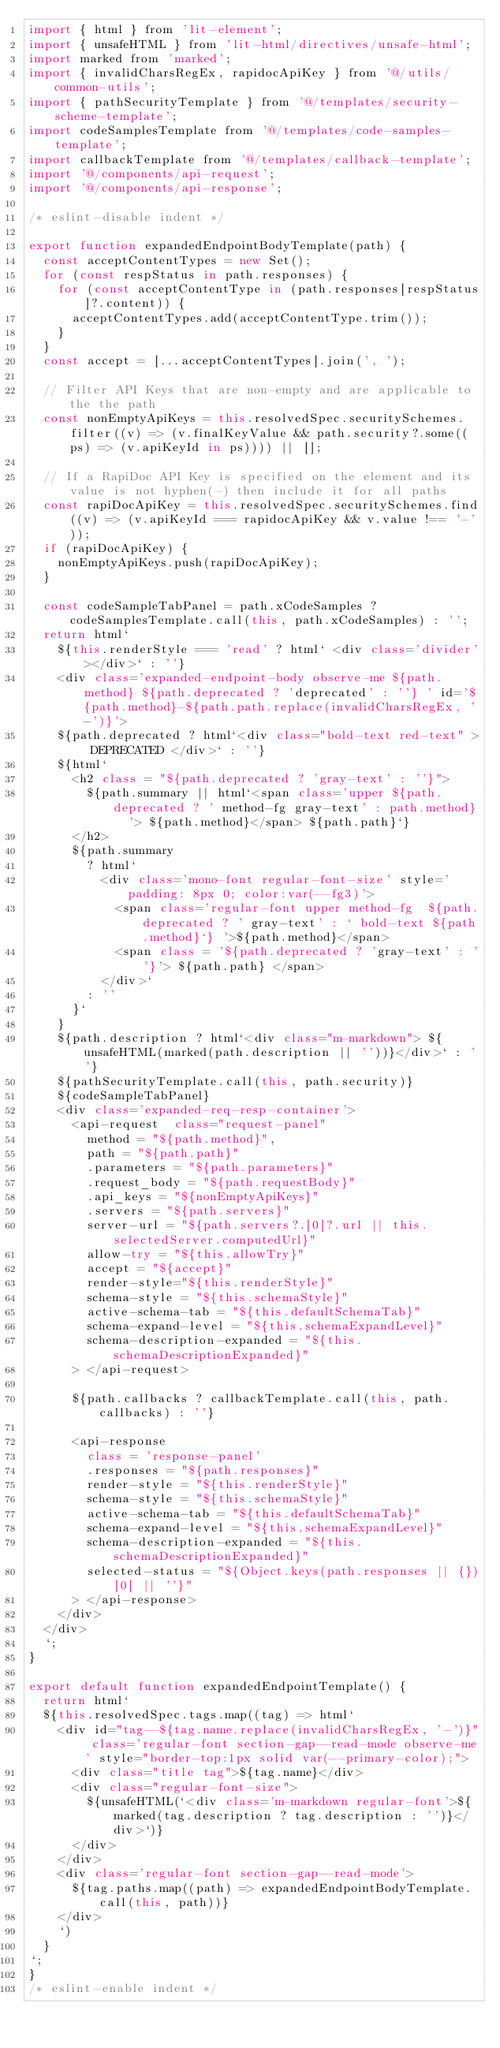<code> <loc_0><loc_0><loc_500><loc_500><_JavaScript_>import { html } from 'lit-element';
import { unsafeHTML } from 'lit-html/directives/unsafe-html';
import marked from 'marked';
import { invalidCharsRegEx, rapidocApiKey } from '@/utils/common-utils';
import { pathSecurityTemplate } from '@/templates/security-scheme-template';
import codeSamplesTemplate from '@/templates/code-samples-template';
import callbackTemplate from '@/templates/callback-template';
import '@/components/api-request';
import '@/components/api-response';

/* eslint-disable indent */

export function expandedEndpointBodyTemplate(path) {
  const acceptContentTypes = new Set();
  for (const respStatus in path.responses) {
    for (const acceptContentType in (path.responses[respStatus]?.content)) {
      acceptContentTypes.add(acceptContentType.trim());
    }
  }
  const accept = [...acceptContentTypes].join(', ');

  // Filter API Keys that are non-empty and are applicable to the the path
  const nonEmptyApiKeys = this.resolvedSpec.securitySchemes.filter((v) => (v.finalKeyValue && path.security?.some((ps) => (v.apiKeyId in ps)))) || [];

  // If a RapiDoc API Key is specified on the element and its value is not hyphen(-) then include it for all paths
  const rapiDocApiKey = this.resolvedSpec.securitySchemes.find((v) => (v.apiKeyId === rapidocApiKey && v.value !== '-'));
  if (rapiDocApiKey) {
    nonEmptyApiKeys.push(rapiDocApiKey);
  }

  const codeSampleTabPanel = path.xCodeSamples ? codeSamplesTemplate.call(this, path.xCodeSamples) : '';
  return html`
    ${this.renderStyle === 'read' ? html` <div class='divider'></div>` : ''}
    <div class='expanded-endpoint-body observe-me ${path.method} ${path.deprecated ? 'deprecated' : ''} ' id='${path.method}-${path.path.replace(invalidCharsRegEx, '-')}'>
    ${path.deprecated ? html`<div class="bold-text red-text" > DEPRECATED </div>` : ''}
    ${html`
      <h2 class = "${path.deprecated ? 'gray-text' : ''}"> 
        ${path.summary || html`<span class='upper ${path.deprecated ? ' method-fg gray-text' : path.method}  '> ${path.method}</span> ${path.path}`} 
      </h2>
      ${path.summary
        ? html`
          <div class='mono-font regular-font-size' style='padding: 8px 0; color:var(--fg3)'> 
            <span class='regular-font upper method-fg  ${path.deprecated ? ' gray-text' : ` bold-text ${path.method}`} '>${path.method}</span> 
            <span class = '${path.deprecated ? 'gray-text' : ''}'> ${path.path} </span>
          </div>`
        : ''
      }`
    }
    ${path.description ? html`<div class="m-markdown"> ${unsafeHTML(marked(path.description || ''))}</div>` : ''}
    ${pathSecurityTemplate.call(this, path.security)}
    ${codeSampleTabPanel}
    <div class='expanded-req-resp-container'>
      <api-request  class="request-panel"  
        method = "${path.method}", 
        path = "${path.path}" 
        .parameters = "${path.parameters}" 
        .request_body = "${path.requestBody}"
        .api_keys = "${nonEmptyApiKeys}"
        .servers = "${path.servers}" 
        server-url = "${path.servers?.[0]?.url || this.selectedServer.computedUrl}" 
        allow-try = "${this.allowTry}"
        accept = "${accept}"
        render-style="${this.renderStyle}" 
        schema-style = "${this.schemaStyle}"
        active-schema-tab = "${this.defaultSchemaTab}"
        schema-expand-level = "${this.schemaExpandLevel}"
        schema-description-expanded = "${this.schemaDescriptionExpanded}"
      > </api-request>

      ${path.callbacks ? callbackTemplate.call(this, path.callbacks) : ''}

      <api-response
        class = 'response-panel'
        .responses = "${path.responses}"
        render-style = "${this.renderStyle}"
        schema-style = "${this.schemaStyle}"
        active-schema-tab = "${this.defaultSchemaTab}"
        schema-expand-level = "${this.schemaExpandLevel}"
        schema-description-expanded = "${this.schemaDescriptionExpanded}"
        selected-status = "${Object.keys(path.responses || {})[0] || ''}"
      > </api-response>
    </div>
  </div>
  `;
}

export default function expandedEndpointTemplate() {
  return html`
  ${this.resolvedSpec.tags.map((tag) => html`
    <div id="tag--${tag.name.replace(invalidCharsRegEx, '-')}" class='regular-font section-gap--read-mode observe-me' style="border-top:1px solid var(--primary-color);">
      <div class="title tag">${tag.name}</div>
      <div class="regular-font-size">
        ${unsafeHTML(`<div class='m-markdown regular-font'>${marked(tag.description ? tag.description : '')}</div>`)}
      </div>
    </div>
    <div class='regular-font section-gap--read-mode'>
      ${tag.paths.map((path) => expandedEndpointBodyTemplate.call(this, path))}
    </div>
    `)
  }
`;
}
/* eslint-enable indent */
</code> 